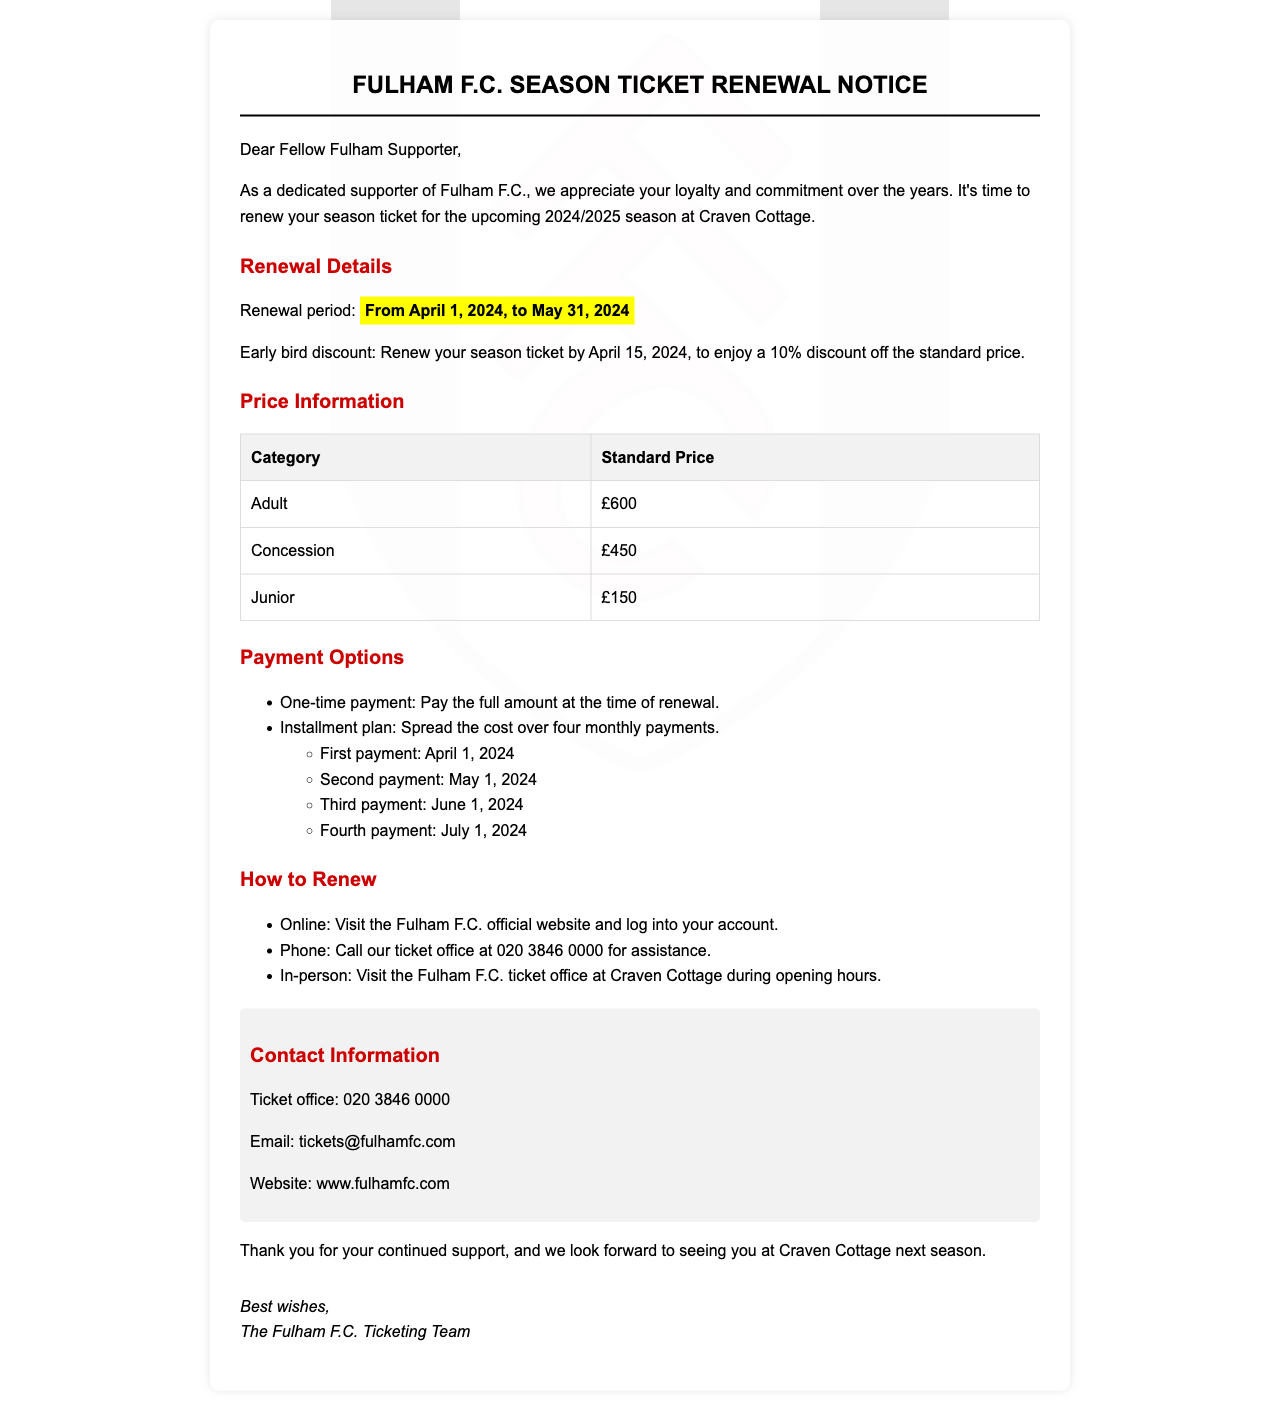What is the renewal period? The renewal period is specified in the document as the timeframe in which season tickets can be renewed.
Answer: From April 1, 2024, to May 31, 2024 What is the early bird discount percentage? The early bird discount is mentioned in the document, which applies if the season ticket is renewed by a certain date.
Answer: 10% What is the standard price for an adult season ticket? The document contains a table with pricing information for different categories, including adults.
Answer: £600 When is the first payment due for the installment plan? The document lists the payment schedule, including due dates for each installment.
Answer: April 1, 2024 How can I renew my season ticket online? The document outlines different methods for renewing the season ticket, with one method specified for online renewal.
Answer: Visit the Fulham F.C. official website What is the contact number for the ticket office? The document provides contact information for the ticket office, including a phone number.
Answer: 020 3846 0000 If I renew my ticket after April 15, what discount will I receive? The document states a specific discount for early renewals; thus, reasoning about the time frame is needed.
Answer: No discount Where is the Fulham F.C. ticket office located? The document mentions the location for in-person renewals, which is a specific venue.
Answer: Craven Cottage What type of document is this? The content and purpose of the letter indicate its function related to a specific event for supporters.
Answer: Season Ticket Renewal Notice 